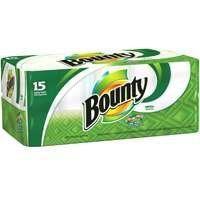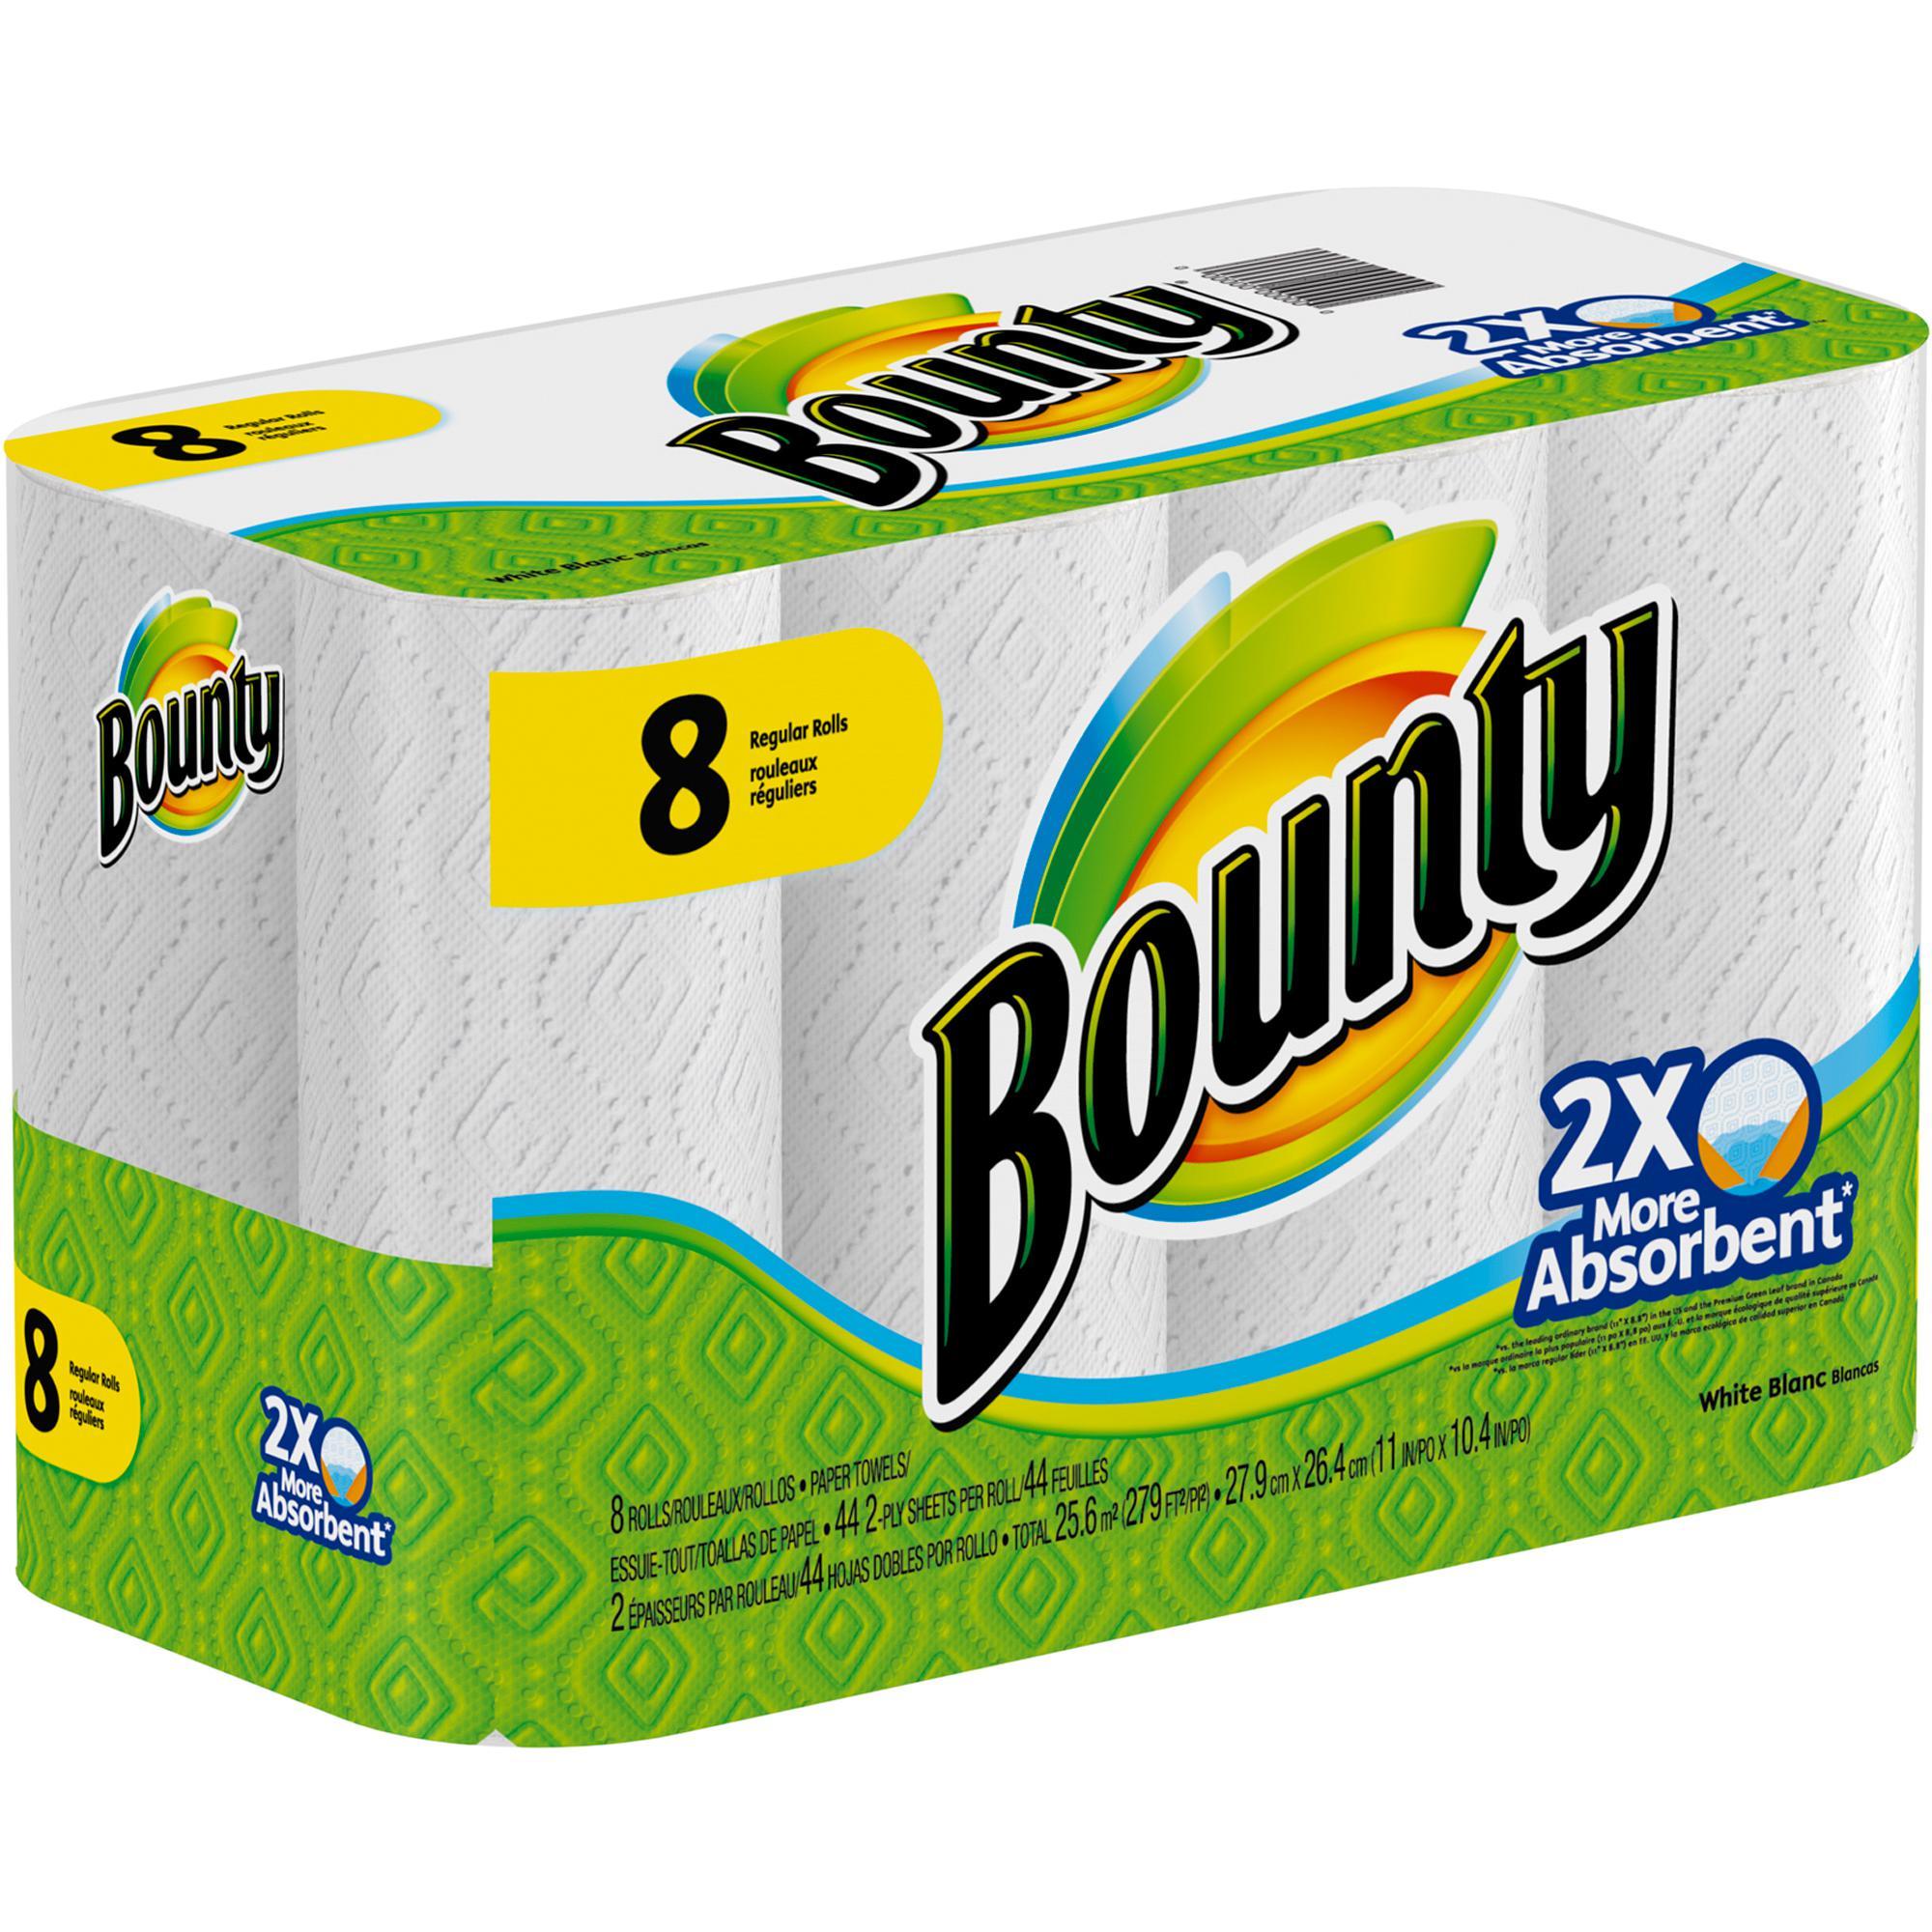The first image is the image on the left, the second image is the image on the right. Evaluate the accuracy of this statement regarding the images: "One multipack of towel rolls has a yellow semi-circle in the upper left, and the other multipack has a yellow curved shape with a double-digit number on it.". Is it true? Answer yes or no. No. The first image is the image on the left, the second image is the image on the right. Assess this claim about the two images: "Every single package of paper towels claims to be 15 rolls worth.". Correct or not? Answer yes or no. No. 